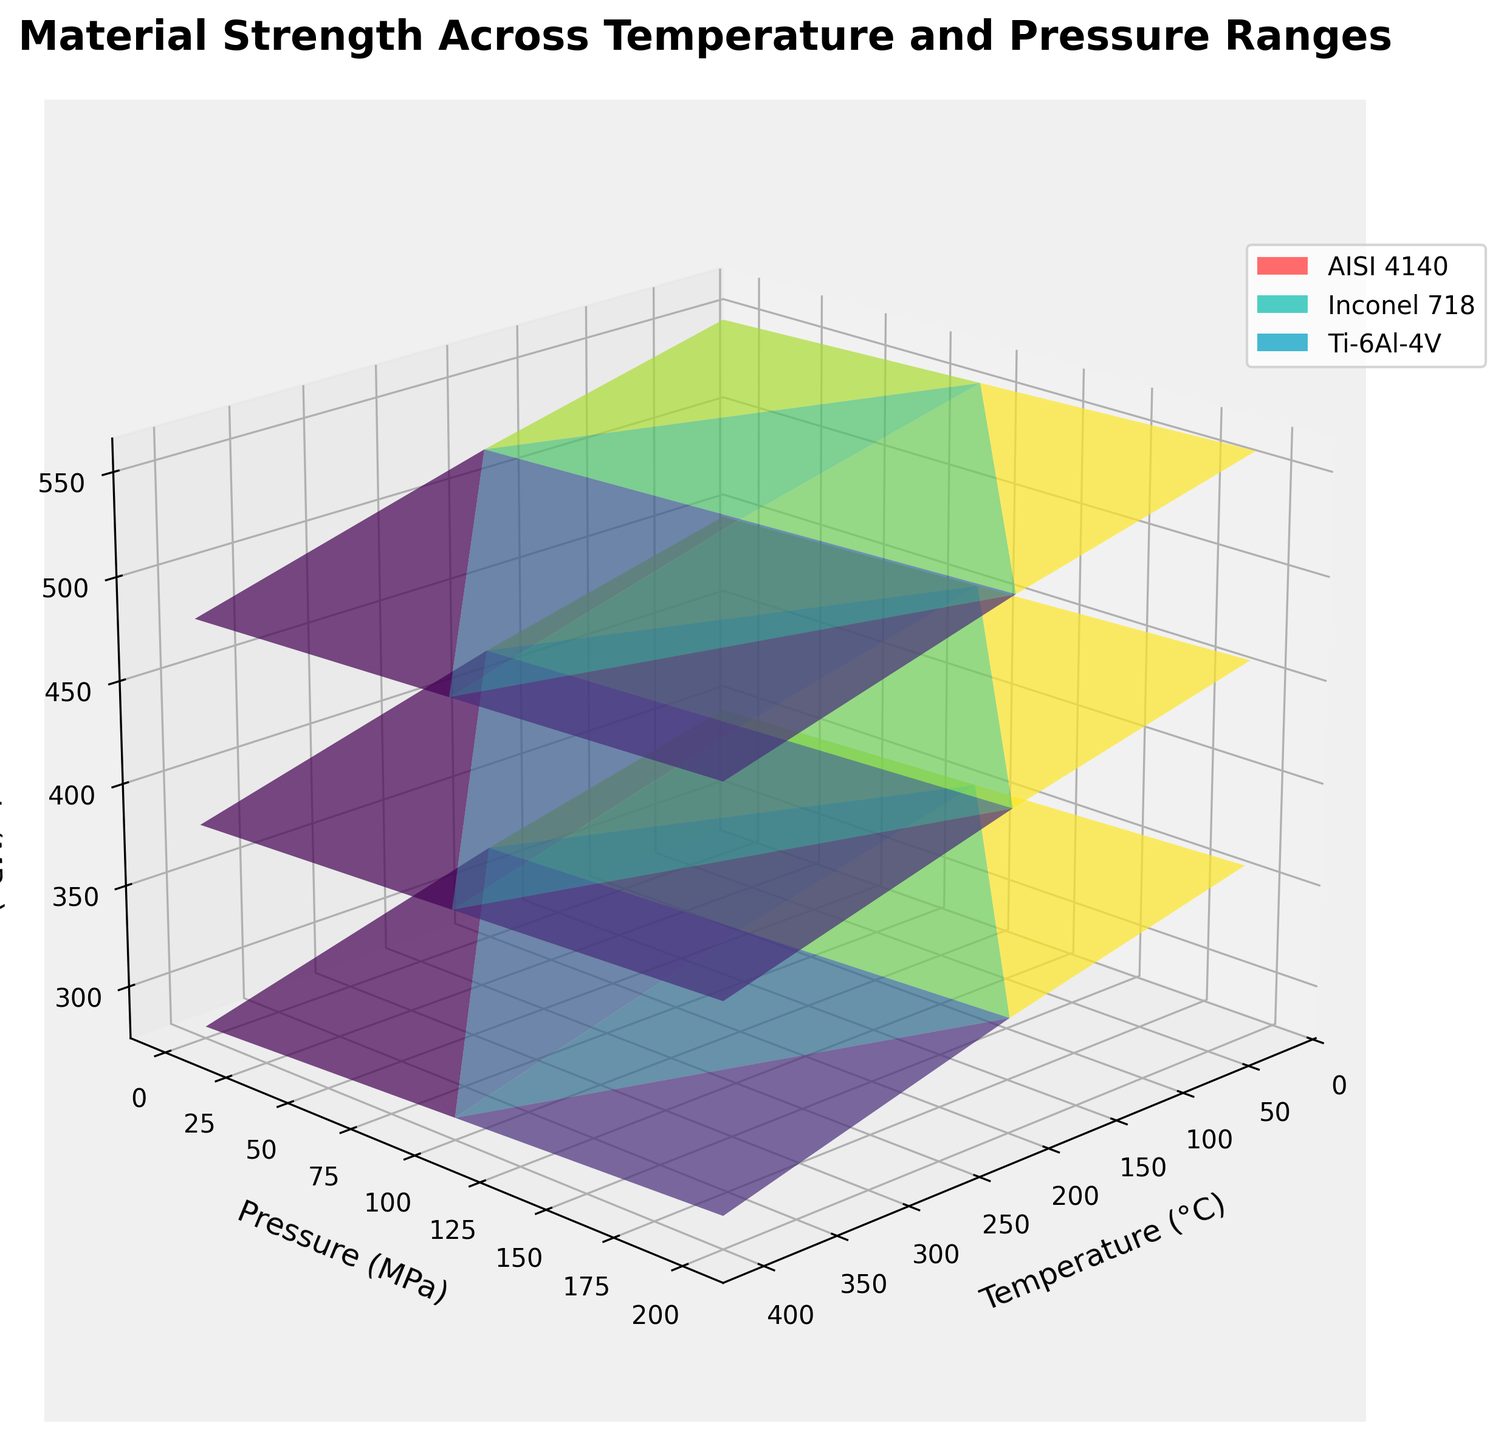What is the title of the plot? The title is displayed at the top of the plot. It is "Material Strength Across Temperature and Pressure Ranges."
Answer: Material Strength Across Temperature and Pressure Ranges What are the labels for the x, y, and z axes? The x, y, and z axes labels are displayed along the respective axes. They are "Temperature (°C)", "Pressure (MPa)", and "Tensile Strength (MPa)" respectively.
Answer: Temperature (°C), Pressure (MPa), Tensile Strength (MPa) How does the tensile strength of AISI 4140 alloy change with increasing temperature at 200 MPa pressure? To answer this, observe the trend of tensile strength values for AISI 4140 along the temperature axis when pressure is set to 200 MPa. The tensile strength decreases from 460 MPa at 25°C to 430 MPa at 200°C and further decreases to 390 MPa at 400°C.
Answer: Decreases Which alloy shows the highest tensile strength at 25°C and 0.1 MPa? Identify the points for each alloy at 25°C and 0.1 MPa and compare their tensile strengths. Inconel 718 shows the highest tensile strength of 550 MPa at these conditions.
Answer: Inconel 718 Comparing AISI 4140 and Ti-6Al-4V alloys, which one has a higher tensile strength at 400°C and 100 MPa? Find the respective data points for both alloys at 400°C and 100 MPa. AISI 4140 has 385 MPa and Ti-6Al-4V has 285 MPa. Therefore, AISI 4140 has a higher tensile strength.
Answer: AISI 4140 What is the range of tensile strength values for Inconel 718 across all temperatures and pressures? Observe the highest and lowest tensile strength points for Inconel 718 on the plot. The tensile strength ranges from 480 MPa to 560 MPa.
Answer: 480 MPa to 560 MPa At 200°C and 200 MPa, which alloy exhibits the lowest tensile strength? Identify the tensile strengths for all three alloys at 200°C and 200 MPa. AISI 4140 has 430 MPa, Inconel 718 has 530 MPa, and Ti-6Al-4V has 330 MPa. Therefore, Ti-6Al-4V exhibits the lowest tensile strength.
Answer: Ti-6Al-4V How does the tensile strength of Ti-6Al-4V change with both temperature and pressure increases from 25°C and 0.1 MPa to 400°C and 200 MPa? Starting from 350 MPa (25°C, 0.1 MPa), observe the trend as temperature and pressure increase. At each progressive stage, the tensile strength decreases, ending at 290 MPa (400°C and 200 MPa).
Answer: Decreases What color is used to represent Inconel 718 in the plot? The legend in the plot assigns colors to each alloy. Inconel 718 is represented with a shade of turquoise or light green.
Answer: Turquoise/light green 